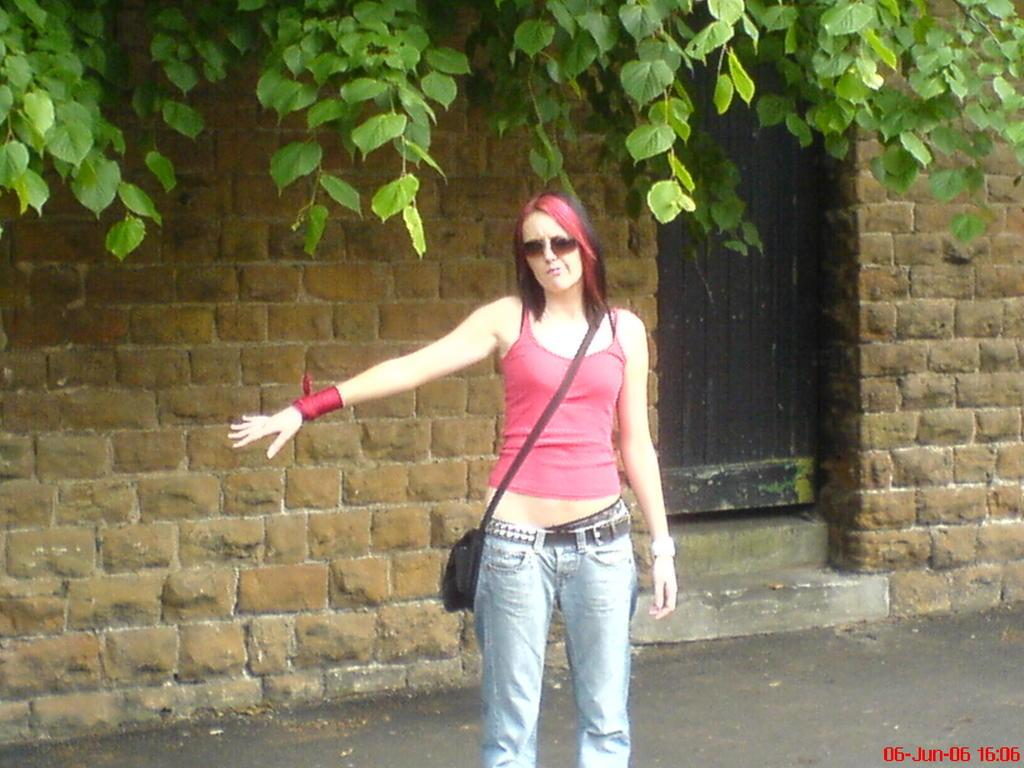Who is present in the image? There is a woman in the image. What is the woman wearing? The woman is wearing a bag. What can be seen in the background of the image? There are walls, a door, and leaves in the background of the image. What type of insurance does the woman have for her bag in the image? There is no information about insurance in the image, as it focuses on the woman and her bag. 